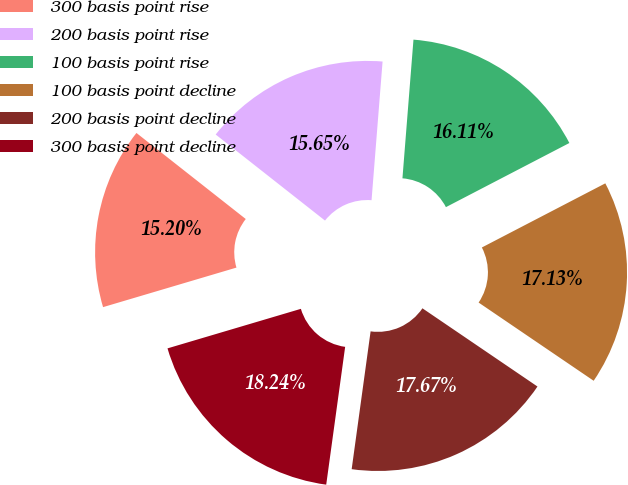Convert chart to OTSL. <chart><loc_0><loc_0><loc_500><loc_500><pie_chart><fcel>300 basis point rise<fcel>200 basis point rise<fcel>100 basis point rise<fcel>100 basis point decline<fcel>200 basis point decline<fcel>300 basis point decline<nl><fcel>15.2%<fcel>15.65%<fcel>16.11%<fcel>17.13%<fcel>17.67%<fcel>18.24%<nl></chart> 